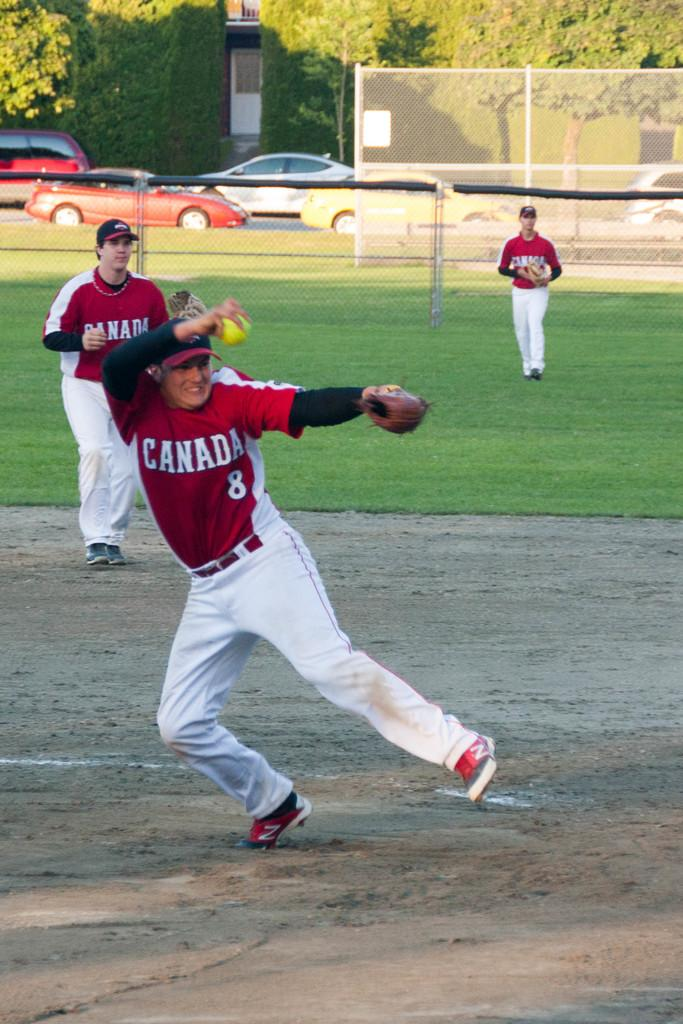<image>
Create a compact narrative representing the image presented. a player that has the word Canada on it 